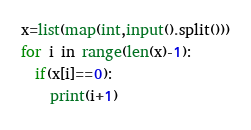Convert code to text. <code><loc_0><loc_0><loc_500><loc_500><_Python_>x=list(map(int,input().split()))
for i in range(len(x)-1):
  if(x[i]==0):
    print(i+1)</code> 